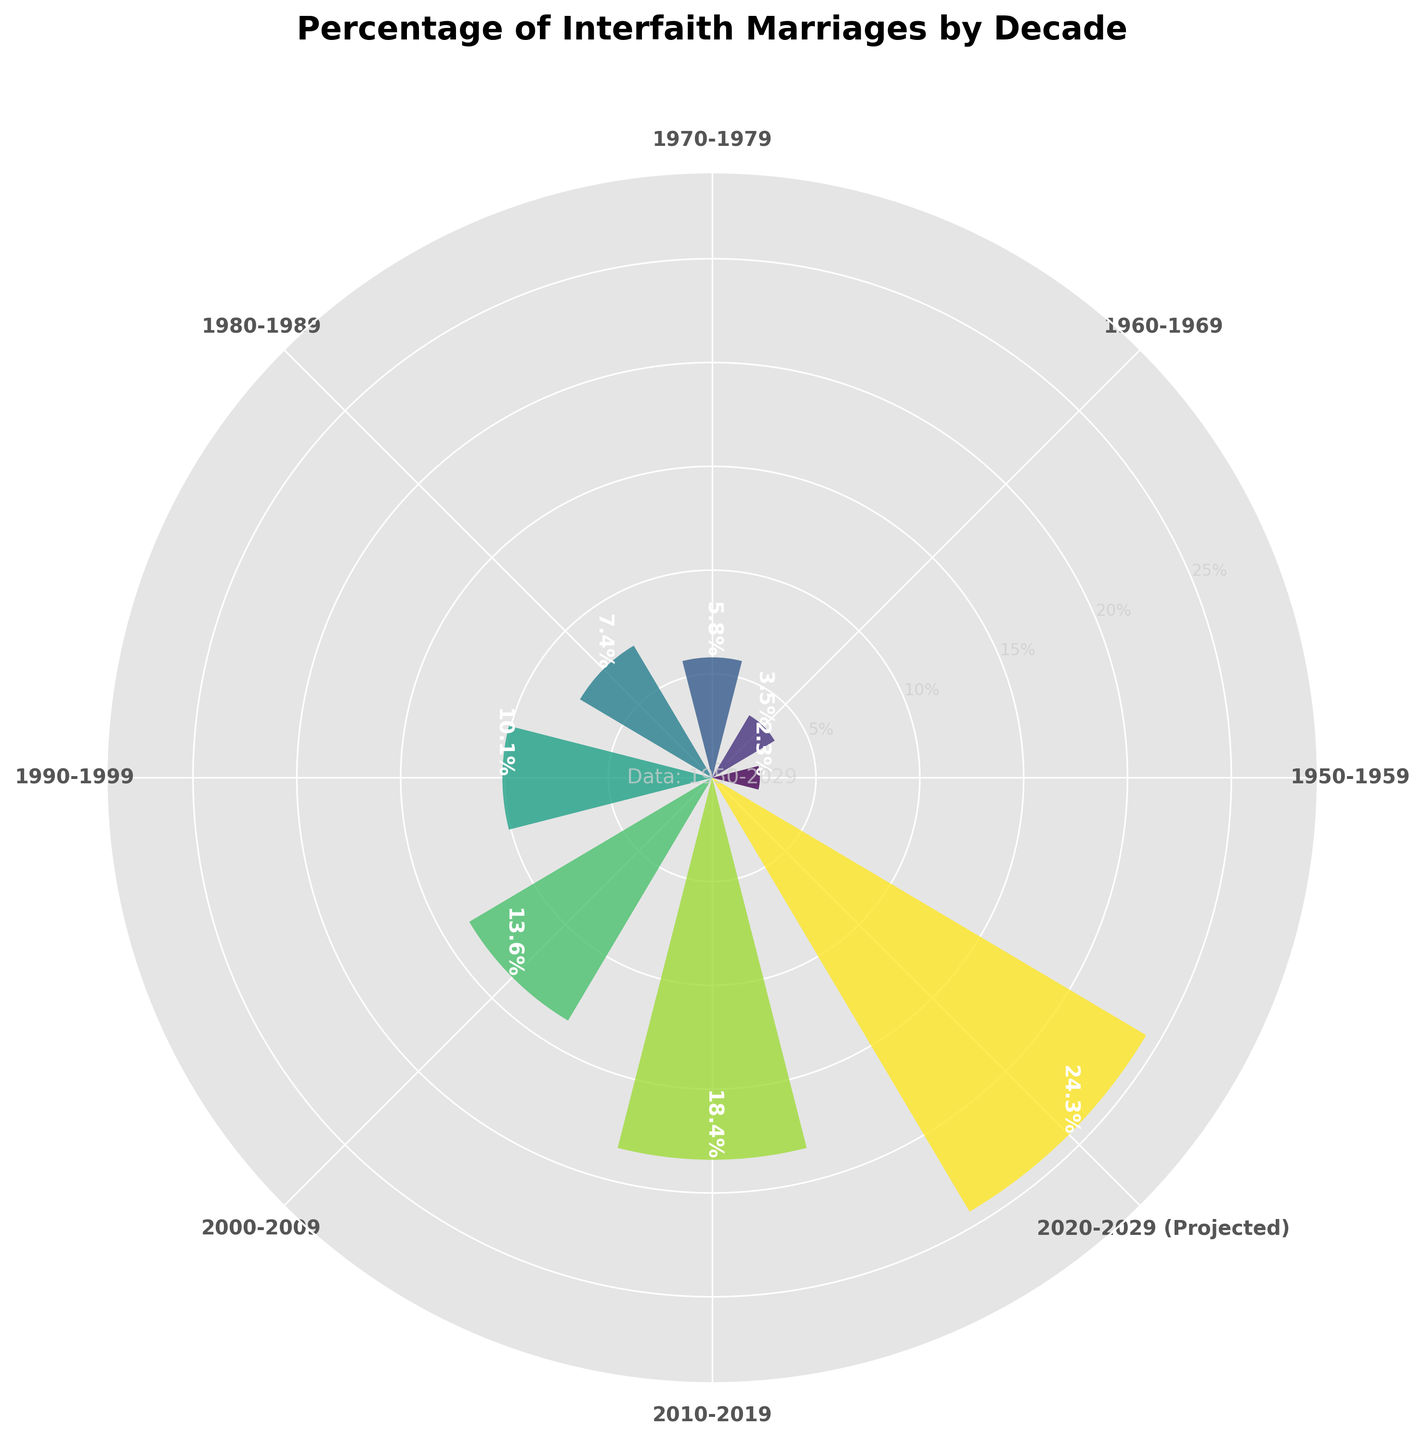What is the title of the rose chart? The title is written at the top of the chart.
Answer: Percentage of Interfaith Marriages by Decade How many decades are represented in the chart? Count the labels on the outer circle of the chart, each representing a decade.
Answer: Eight Which decade has the highest percentage of interfaith marriages? Identify the bar that is the longest and check its label.
Answer: 2020-2029 (Projected) How does the percentage of interfaith marriages in the 1970s compare to the 2010s? Locate the bars for these decades and compare their heights. The label and numerical values can be read from the bars.
Answer: The percentage in the 2010s (18.4%) is higher than in the 1970s (5.8%) What is the approximate percentage increase in interfaith marriages from the 1980s to the 2000s? Subtract the percentage in the 1980s from the percentage in the 2000s and then divide by the percentage in the 1980s, multiply by 100 to get the percentage increase.
Answer: ((13.6 - 7.4) / 7.4) * 100 = 83.78% What trend do you observe in the percentage of interfaith marriages from 1950 to the 2020s (projected)? Observe the increasing lengths of the bars from left to right on the rose chart. This visually indicates an upward trend.
Answer: An increasing trend Which two consecutive decades show the largest increase in the percentage of interfaith marriages? Compare the differences between each consecutive decade by subtracting the previous decade's percentage from the current decade's percentage.
Answer: 2010-2019 and 2020-2029 What is the projected percentage of interfaith marriages in the 2020s, and how does it compare to the previous decade? Read the percentage labeled on the bar for the 2020s and compare it to the labeled percentage for the 2010s.
Answer: 24.3%, an increase of 5.9% from the 2010s What visual feature represents the data magnitude in this rose chart? Observe how the lengths of the bars extend outward from the center in the rose chart. The longer the bar, the higher the percentage.
Answer: Length of the bars 